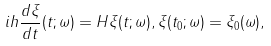<formula> <loc_0><loc_0><loc_500><loc_500>i h \frac { d \xi } { d t } ( t ; \omega ) = { H } \xi ( t ; \omega ) , \xi ( t _ { 0 } ; \omega ) = \xi _ { 0 } ( \omega ) ,</formula> 